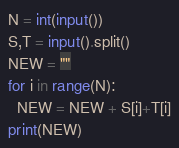<code> <loc_0><loc_0><loc_500><loc_500><_Python_>N = int(input())
S,T = input().split()
NEW = ""
for i in range(N):
  NEW = NEW + S[i]+T[i]
print(NEW)</code> 